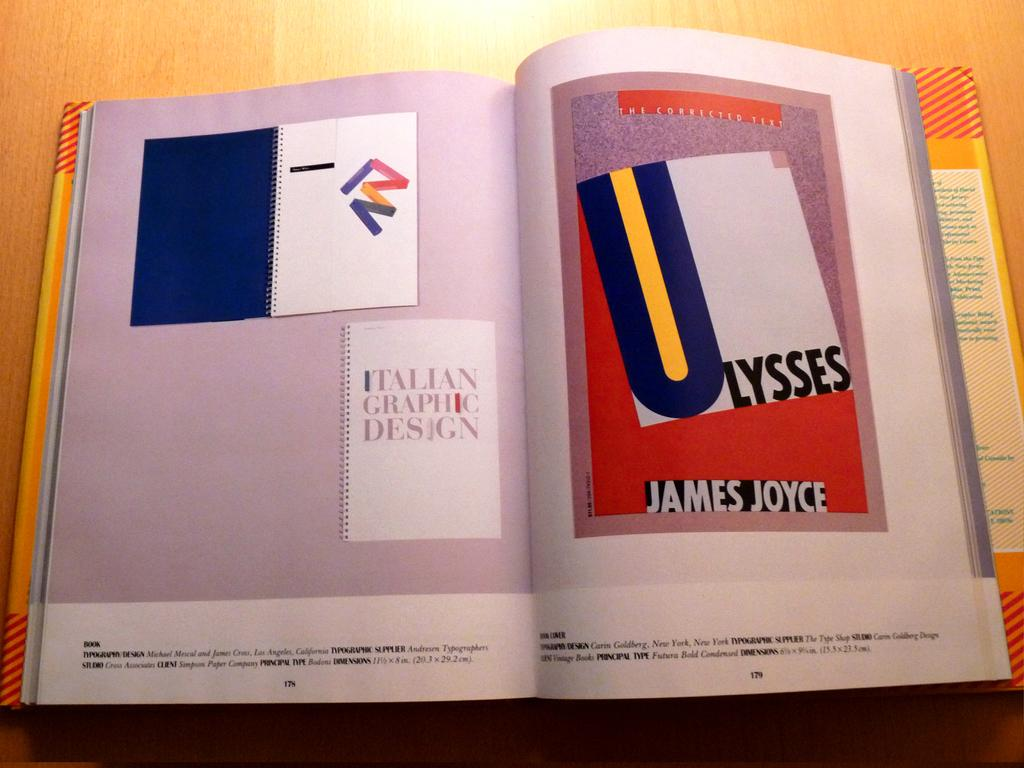Provide a one-sentence caption for the provided image. a book which has a print of James Joyce's Ulysees on it. 